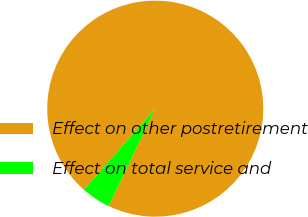Convert chart. <chart><loc_0><loc_0><loc_500><loc_500><pie_chart><fcel>Effect on other postretirement<fcel>Effect on total service and<nl><fcel>95.61%<fcel>4.39%<nl></chart> 